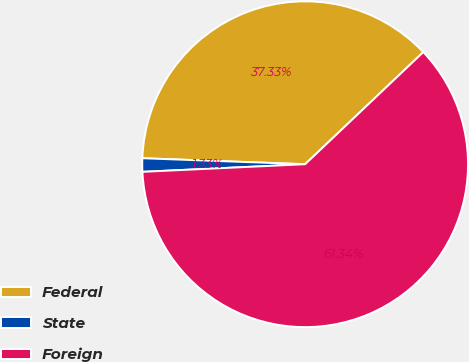<chart> <loc_0><loc_0><loc_500><loc_500><pie_chart><fcel>Federal<fcel>State<fcel>Foreign<nl><fcel>37.33%<fcel>1.33%<fcel>61.33%<nl></chart> 